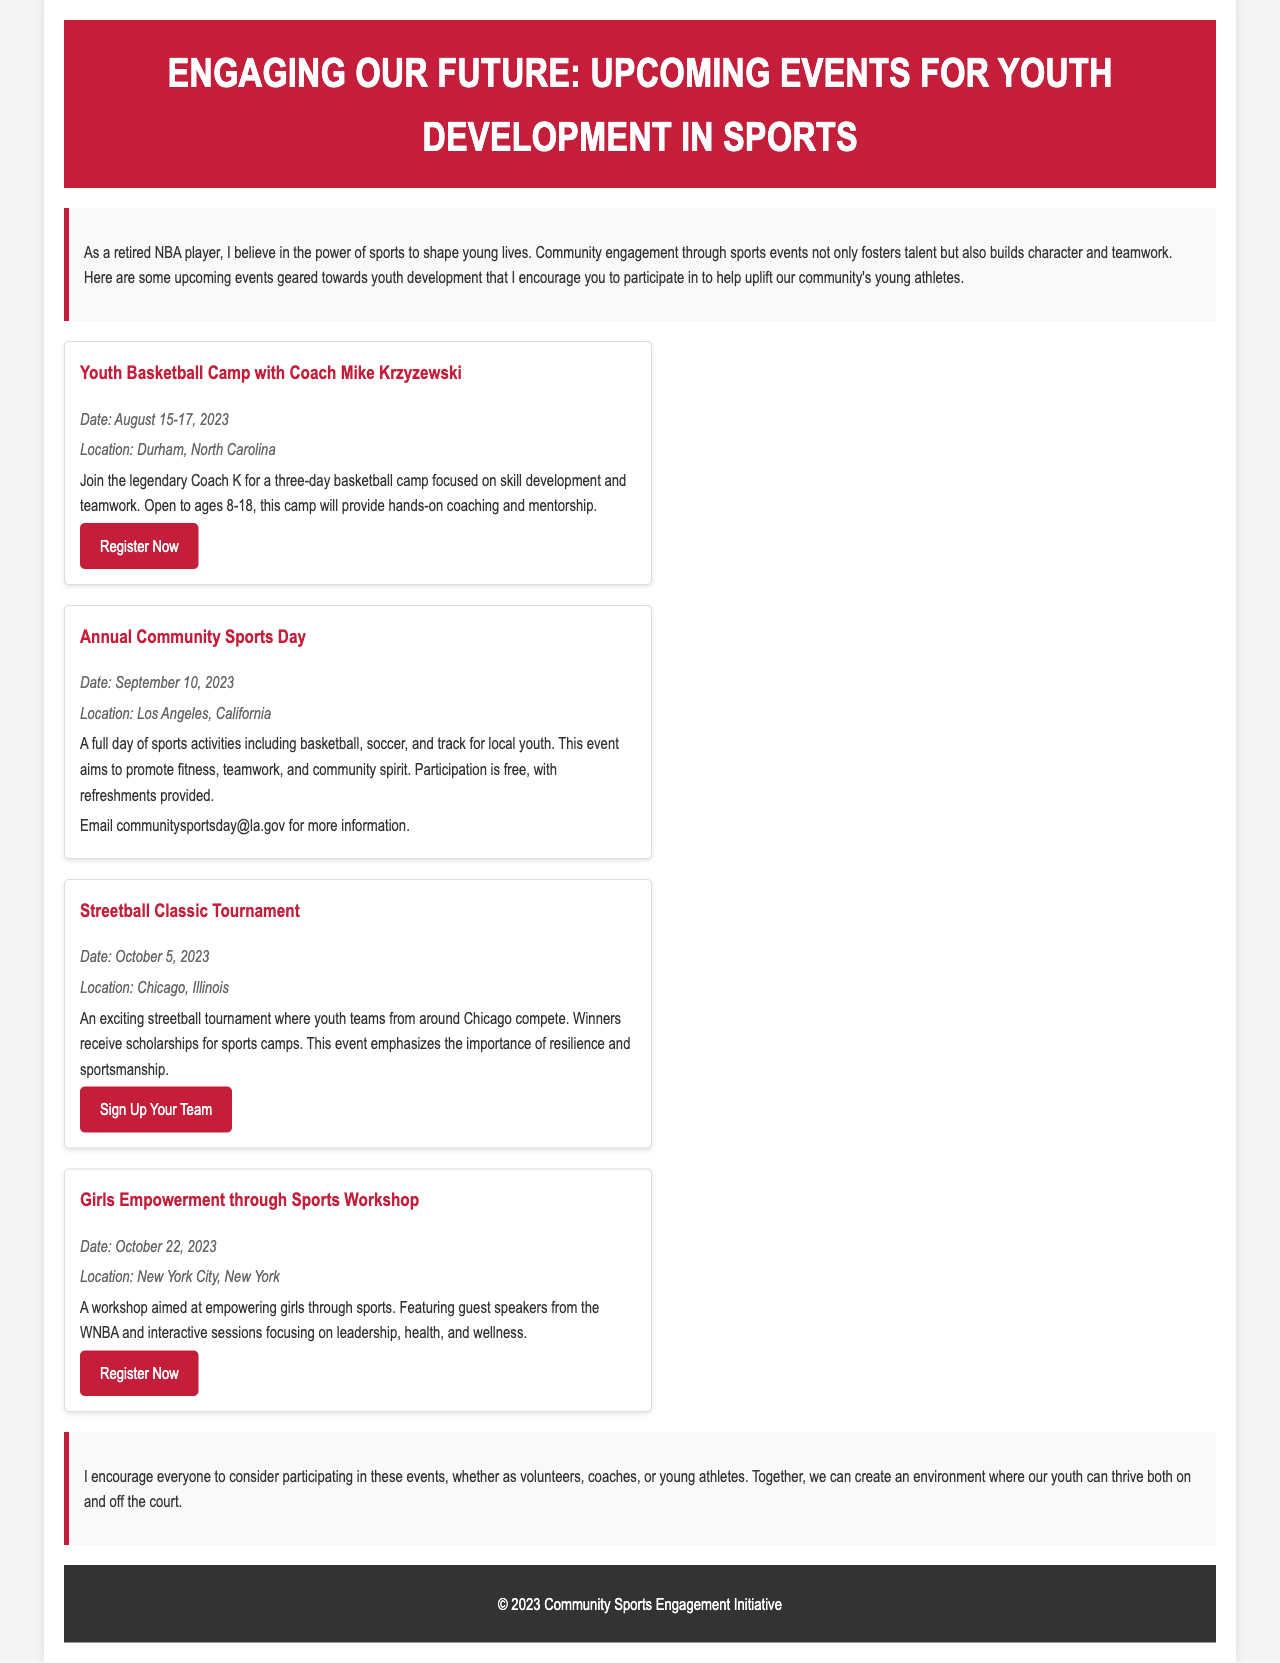What is the title of the newsletter? The title is the first line in the header section of the document.
Answer: Engaging Our Future: Upcoming Events for Youth Development in Sports Who is the camp hosted by? The camp is mentioned with a specific coach in the event details.
Answer: Coach Mike Krzyzewski What is the date of the Annual Community Sports Day? The date is explicitly listed in the details of the second event.
Answer: September 10, 2023 Where is the Girls Empowerment through Sports Workshop taking place? The location is specified in the details of the last event.
Answer: New York City, New York What is the main objective of the Streetball Classic Tournament? The objective is mentioned in the description of the event.
Answer: Emphasizing resilience and sportsmanship How many days is the Youth Basketball Camp? The duration is mentioned in the event description.
Answer: Three days What type of food is provided at the Annual Community Sports Day? This detail is included in the event description.
Answer: Refreshments What kinds of sports are included in the Annual Community Sports Day? The types of sports are explicitly listed in the event description.
Answer: Basketball, soccer, and track What is the purpose of the workshop aimed at girls? The purpose is stated in the description of the workshop event.
Answer: Empowering girls through sports 